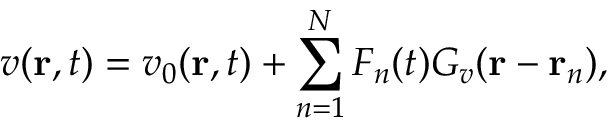<formula> <loc_0><loc_0><loc_500><loc_500>v ( r , t ) = v _ { 0 } ( r , t ) + \sum _ { n = 1 } ^ { N } F _ { n } ( t ) G _ { v } ( r - r _ { n } ) ,</formula> 